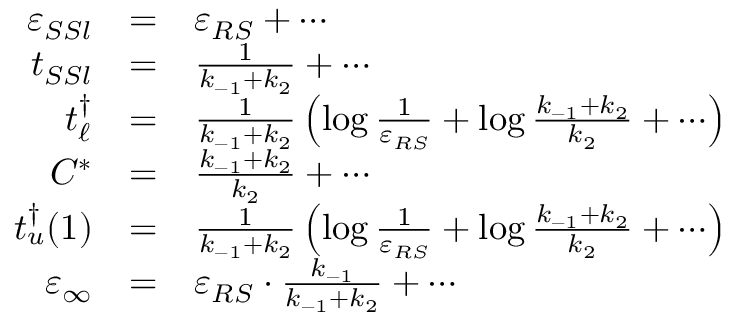Convert formula to latex. <formula><loc_0><loc_0><loc_500><loc_500>\begin{array} { r c l } { \varepsilon _ { S S l } } & { = } & { \varepsilon _ { R S } + \cdots } \\ { t _ { S S l } } & { = } & { \frac { 1 } { k _ { - 1 } + k _ { 2 } } + \cdots } \\ { t _ { \ell } ^ { \dagger } } & { = } & { \frac { 1 } { k _ { - 1 } + k _ { 2 } } \left ( \log \frac { 1 } { \varepsilon _ { R S } } + \log \frac { k _ { - 1 } + k _ { 2 } } { k _ { 2 } } + \cdots \right ) } \\ { C ^ { * } } & { = } & { \frac { k _ { - 1 } + k _ { 2 } } { k _ { 2 } } + \cdots } \\ { t _ { u } ^ { \dagger } ( 1 ) } & { = } & { \frac { 1 } { k _ { - 1 } + k _ { 2 } } \left ( \log \frac { 1 } { \varepsilon _ { R S } } + \log \frac { k _ { - 1 } + k _ { 2 } } { k _ { 2 } } + \cdots \right ) } \\ { \varepsilon _ { \infty } } & { = } & { \varepsilon _ { R S } \cdot \frac { k _ { - 1 } } { k _ { - 1 } + k _ { 2 } } + \cdots } \end{array}</formula> 